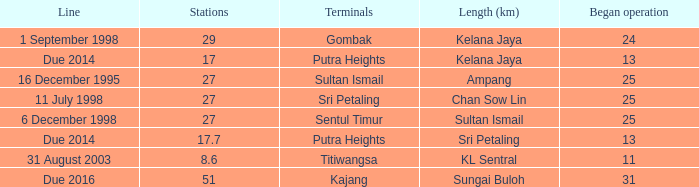What is the average operation beginning with a length of ampang and over 27 stations? None. 